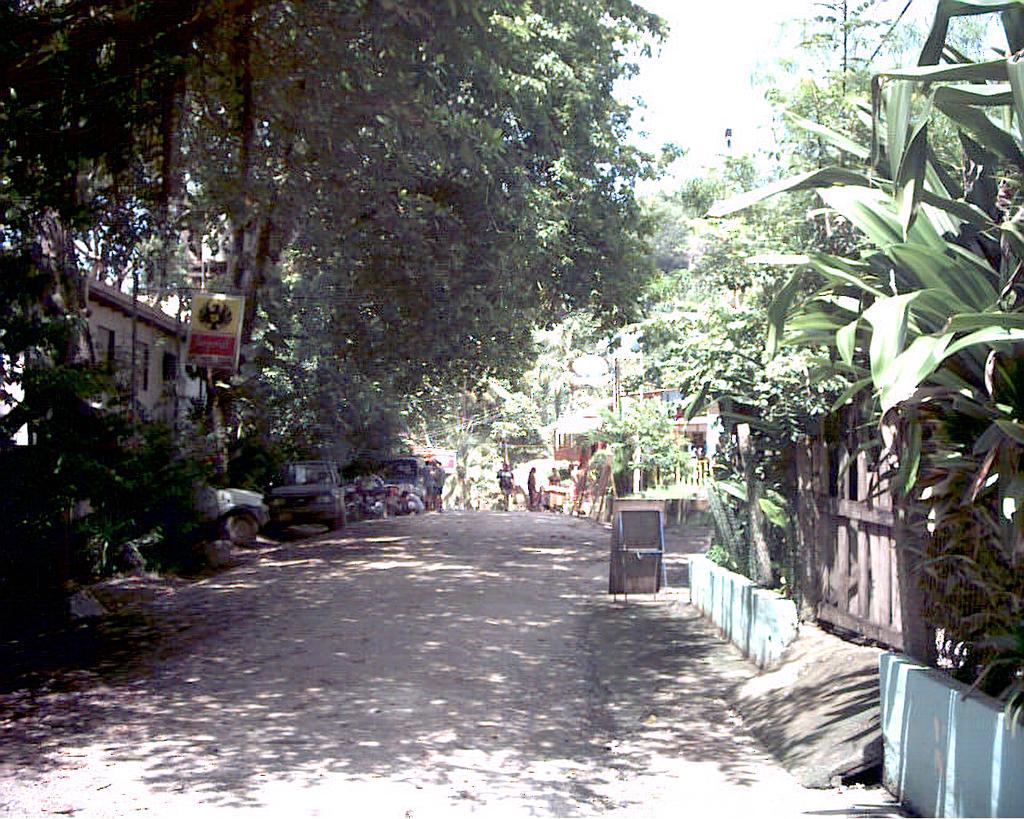Describe this image in one or two sentences. There are vehicles and few persons. Here we can see trees, plants, fence, board, houses, and a road. In the background we can see sky. 